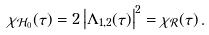Convert formula to latex. <formula><loc_0><loc_0><loc_500><loc_500>\chi _ { \mathcal { H } _ { 0 } } ( \tau ) = 2 \left | \Lambda _ { 1 , 2 } ( \tau ) \right | ^ { 2 } = \chi _ { \mathcal { R } } ( \tau ) \, .</formula> 